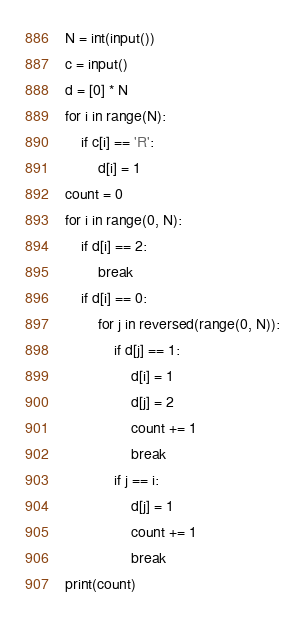Convert code to text. <code><loc_0><loc_0><loc_500><loc_500><_Python_>N = int(input())
c = input()
d = [0] * N
for i in range(N):
    if c[i] == 'R':
        d[i] = 1
count = 0
for i in range(0, N):
    if d[i] == 2:
        break
    if d[i] == 0:
        for j in reversed(range(0, N)):
            if d[j] == 1:
                d[i] = 1
                d[j] = 2
                count += 1
                break
            if j == i:
                d[j] = 1
                count += 1
                break
print(count)</code> 